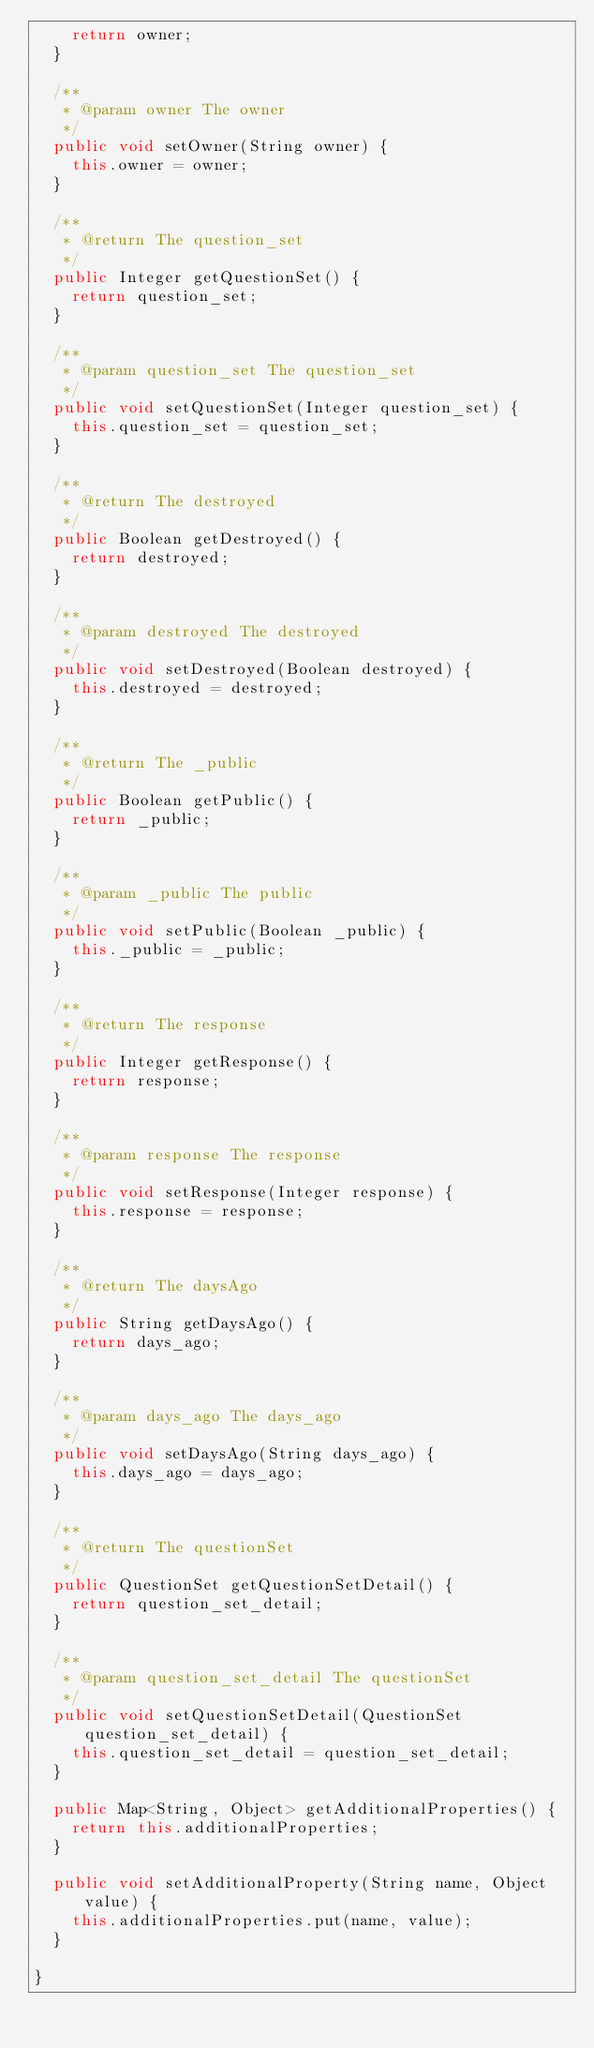<code> <loc_0><loc_0><loc_500><loc_500><_Java_>		return owner;
	}

	/**
	 * @param owner The owner
	 */
	public void setOwner(String owner) {
		this.owner = owner;
	}

	/**
	 * @return The question_set
	 */
	public Integer getQuestionSet() {
		return question_set;
	}

	/**
	 * @param question_set The question_set
	 */
	public void setQuestionSet(Integer question_set) {
		this.question_set = question_set;
	}

	/**
	 * @return The destroyed
	 */
	public Boolean getDestroyed() {
		return destroyed;
	}

	/**
	 * @param destroyed The destroyed
	 */
	public void setDestroyed(Boolean destroyed) {
		this.destroyed = destroyed;
	}

	/**
	 * @return The _public
	 */
	public Boolean getPublic() {
		return _public;
	}

	/**
	 * @param _public The public
	 */
	public void setPublic(Boolean _public) {
		this._public = _public;
	}

	/**
	 * @return The response
	 */
	public Integer getResponse() {
		return response;
	}

	/**
	 * @param response The response
	 */
	public void setResponse(Integer response) {
		this.response = response;
	}

	/**
	 * @return The daysAgo
	 */
	public String getDaysAgo() {
		return days_ago;
	}

	/**
	 * @param days_ago The days_ago
	 */
	public void setDaysAgo(String days_ago) {
		this.days_ago = days_ago;
	}

	/**
	 * @return The questionSet
	 */
	public QuestionSet getQuestionSetDetail() {
		return question_set_detail;
	}

	/**
	 * @param question_set_detail The questionSet
	 */
	public void setQuestionSetDetail(QuestionSet question_set_detail) {
		this.question_set_detail = question_set_detail;
	}

	public Map<String, Object> getAdditionalProperties() {
		return this.additionalProperties;
	}

	public void setAdditionalProperty(String name, Object value) {
		this.additionalProperties.put(name, value);
	}

}</code> 